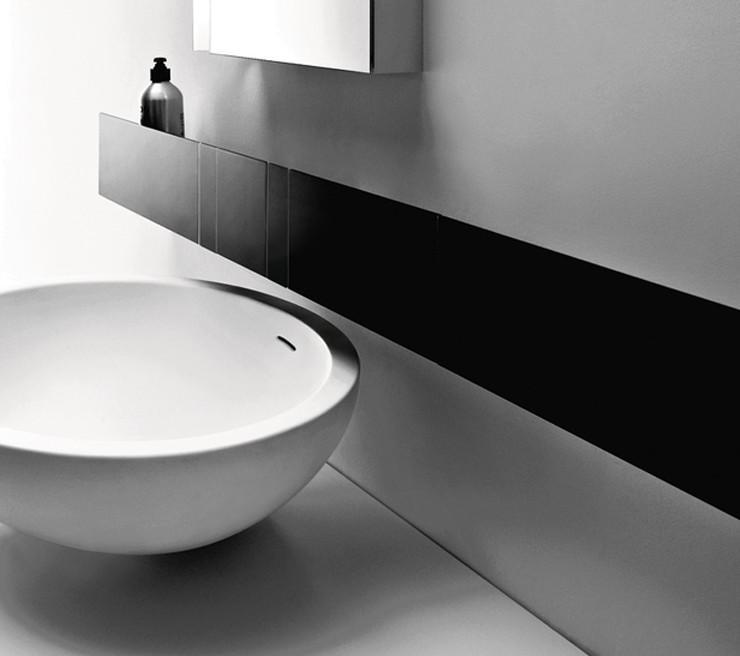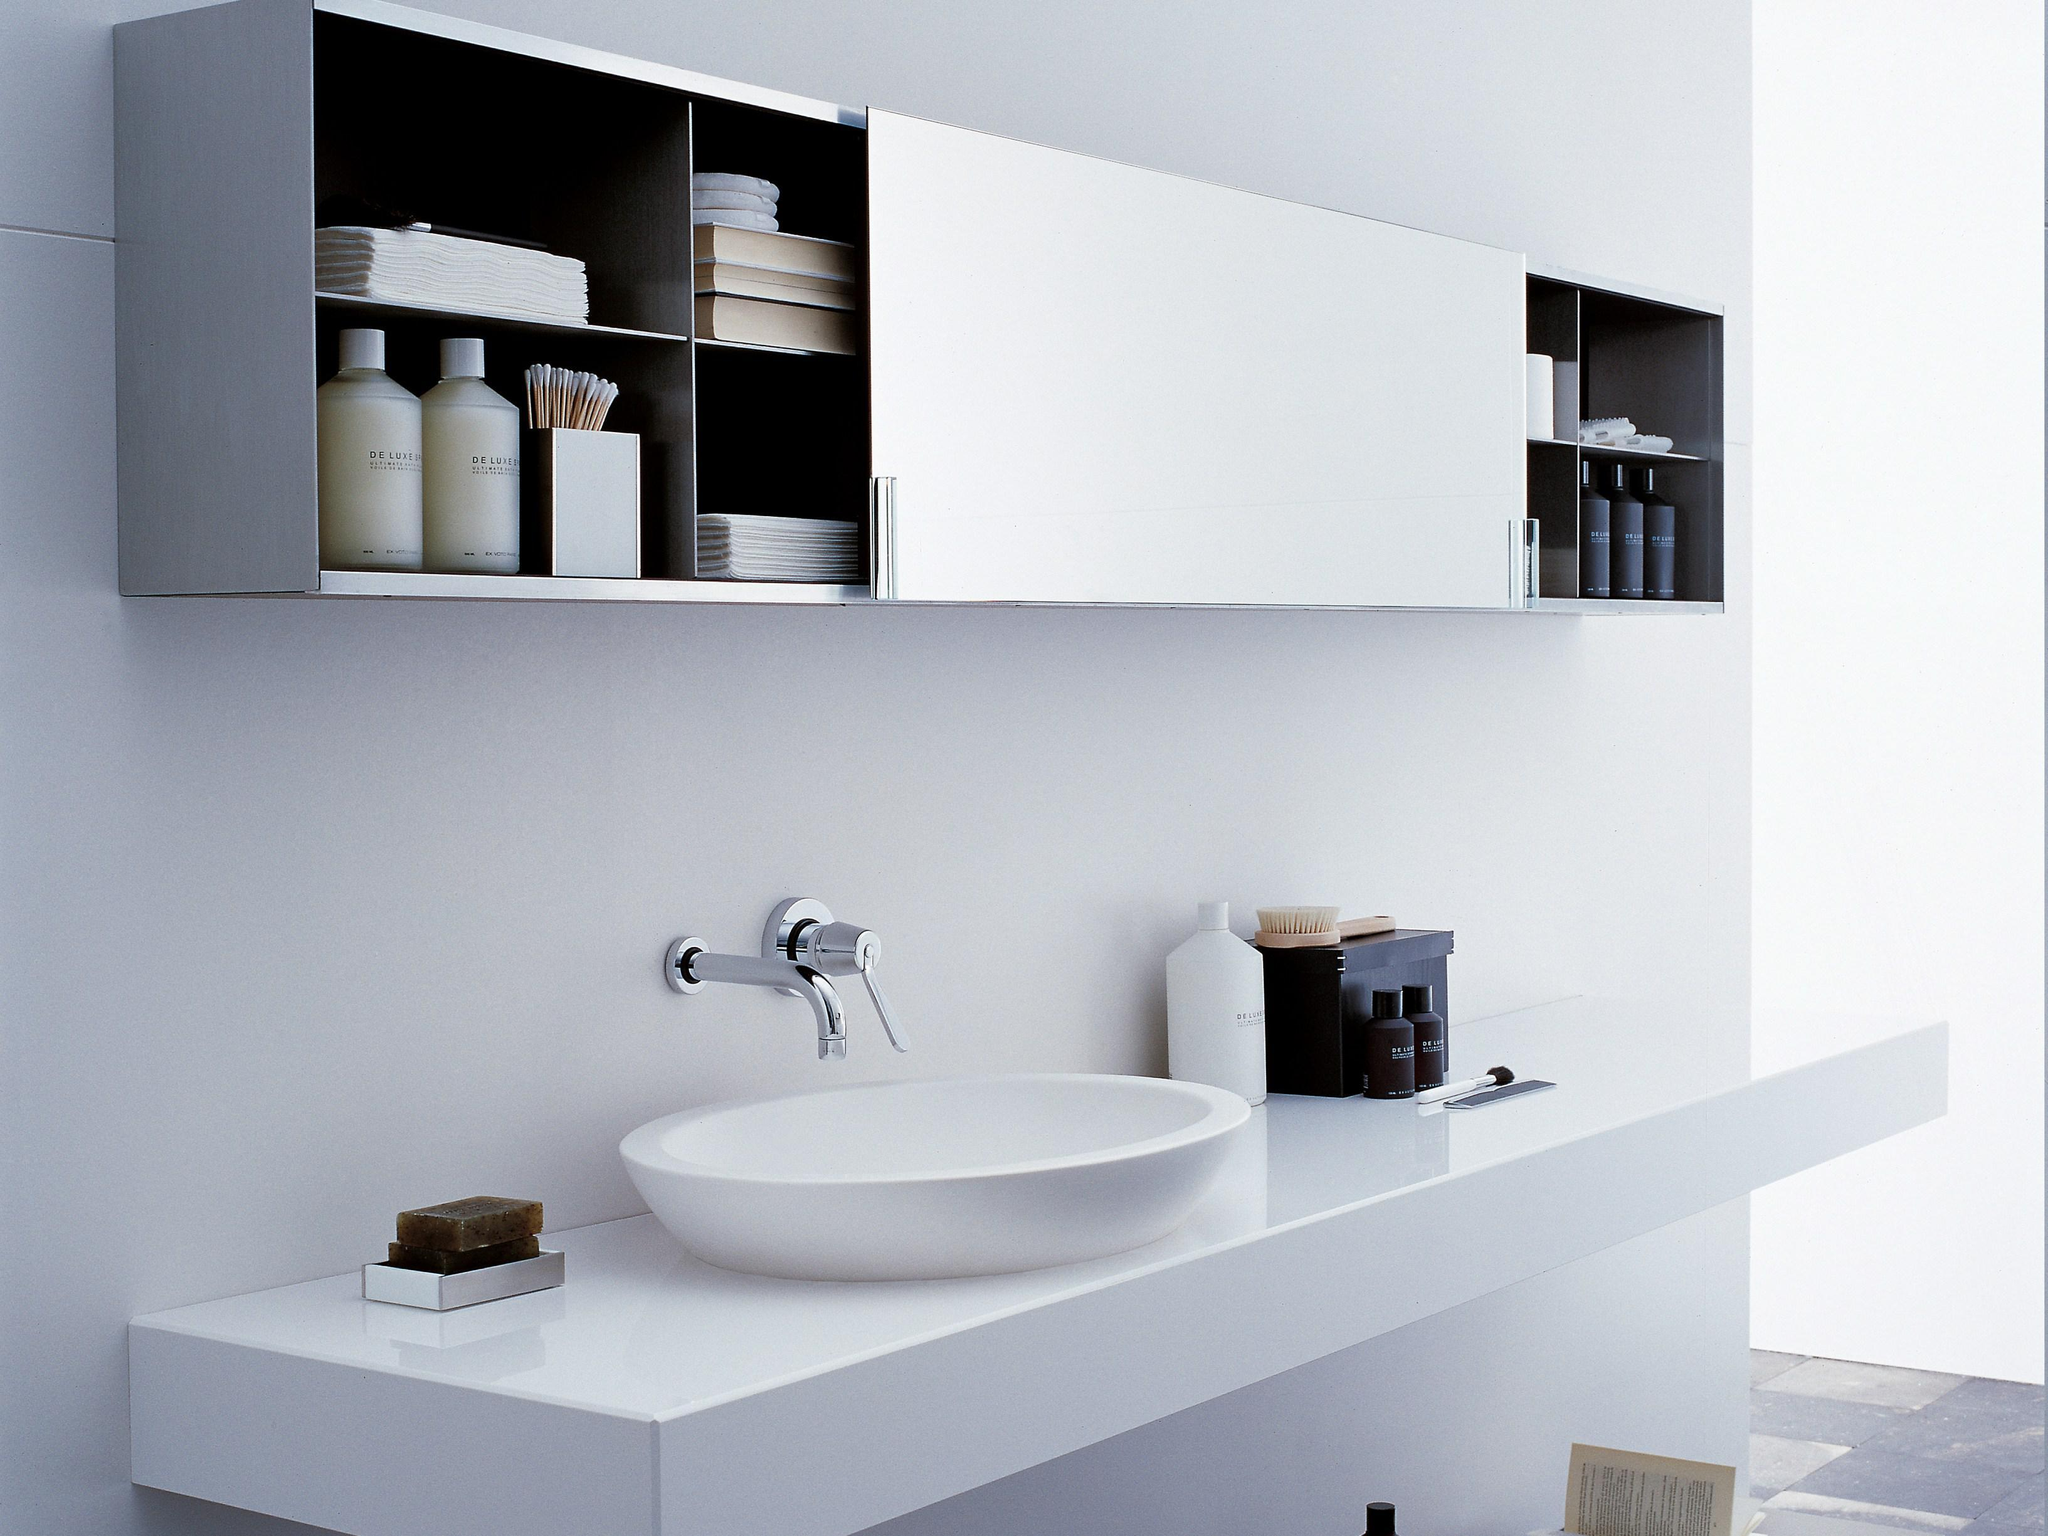The first image is the image on the left, the second image is the image on the right. For the images shown, is this caption "In one of the images, a bar of soap can be seen next to a sink." true? Answer yes or no. Yes. The first image is the image on the left, the second image is the image on the right. Considering the images on both sides, is "There are bars of soap on the left side of a wash basin in the right image." valid? Answer yes or no. Yes. 